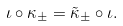Convert formula to latex. <formula><loc_0><loc_0><loc_500><loc_500>\iota \circ \kappa _ { \pm } = \tilde { \kappa } _ { \pm } \circ \iota .</formula> 